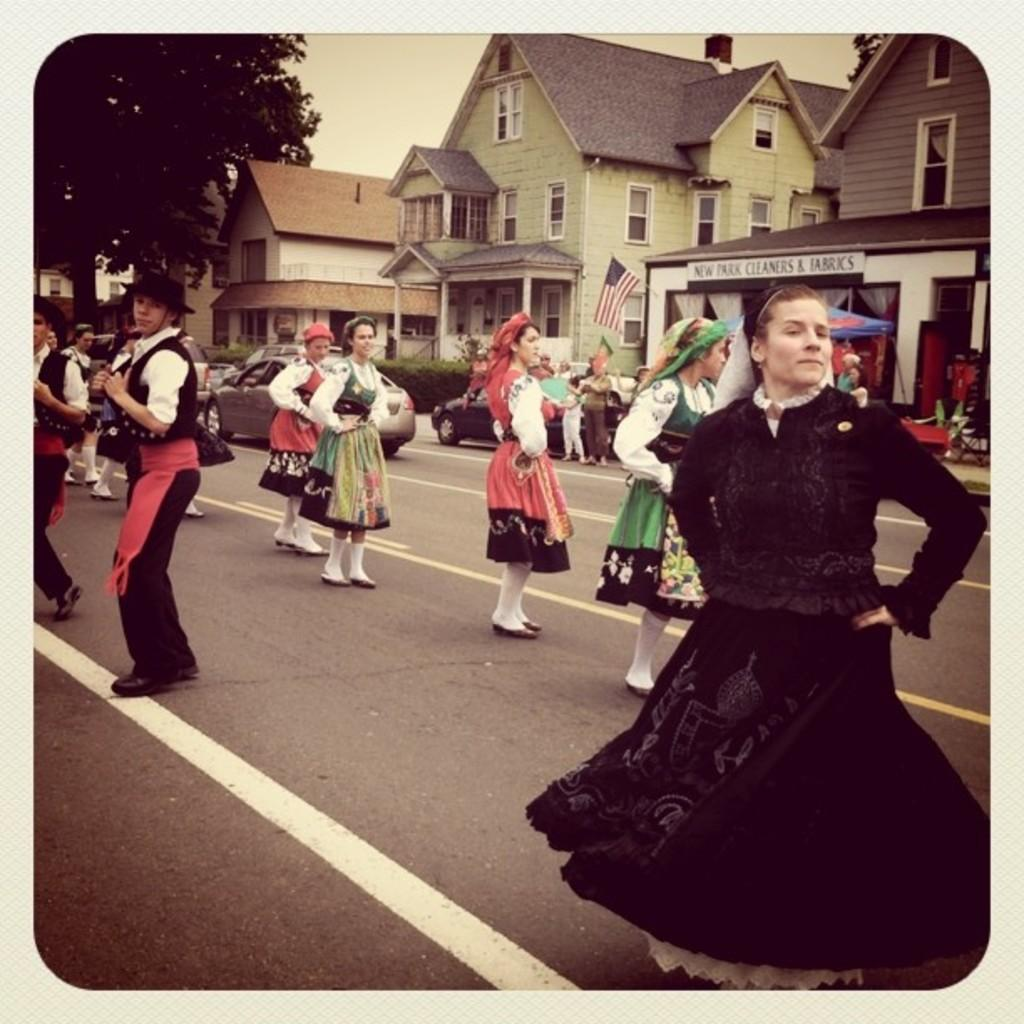What is depicted on the album page in the image? There is a photograph on an album page in the image. What are the persons in the photograph doing? In the photograph, there are persons dancing on the road. What else can be seen in the photograph besides the dancing persons? Vehicles, buildings, windows, a tree, a flag, and other objects are visible in the photograph. What part of the natural environment is visible in the photograph? The sky is visible in the photograph. What type of harmony can be heard in the background of the photograph? There is no audible sound in the photograph, so it is not possible to determine the type of harmony present. 